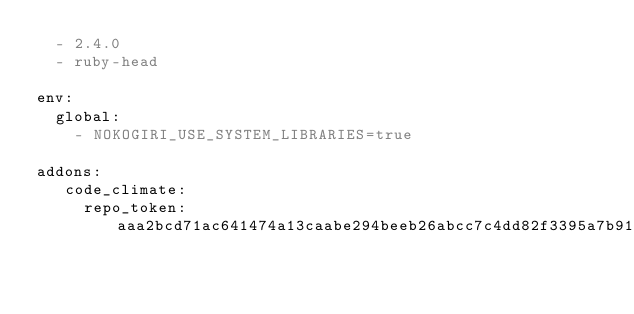Convert code to text. <code><loc_0><loc_0><loc_500><loc_500><_YAML_>  - 2.4.0
  - ruby-head

env:
  global:
    - NOKOGIRI_USE_SYSTEM_LIBRARIES=true

addons:
   code_climate:
     repo_token: aaa2bcd71ac641474a13caabe294beeb26abcc7c4dd82f3395a7b9193bb20d02

</code> 